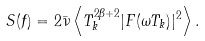<formula> <loc_0><loc_0><loc_500><loc_500>S ( f ) = 2 \bar { \nu } \left \langle T _ { k } ^ { 2 \beta + 2 } | F ( \omega T _ { k } ) | ^ { 2 } \right \rangle .</formula> 